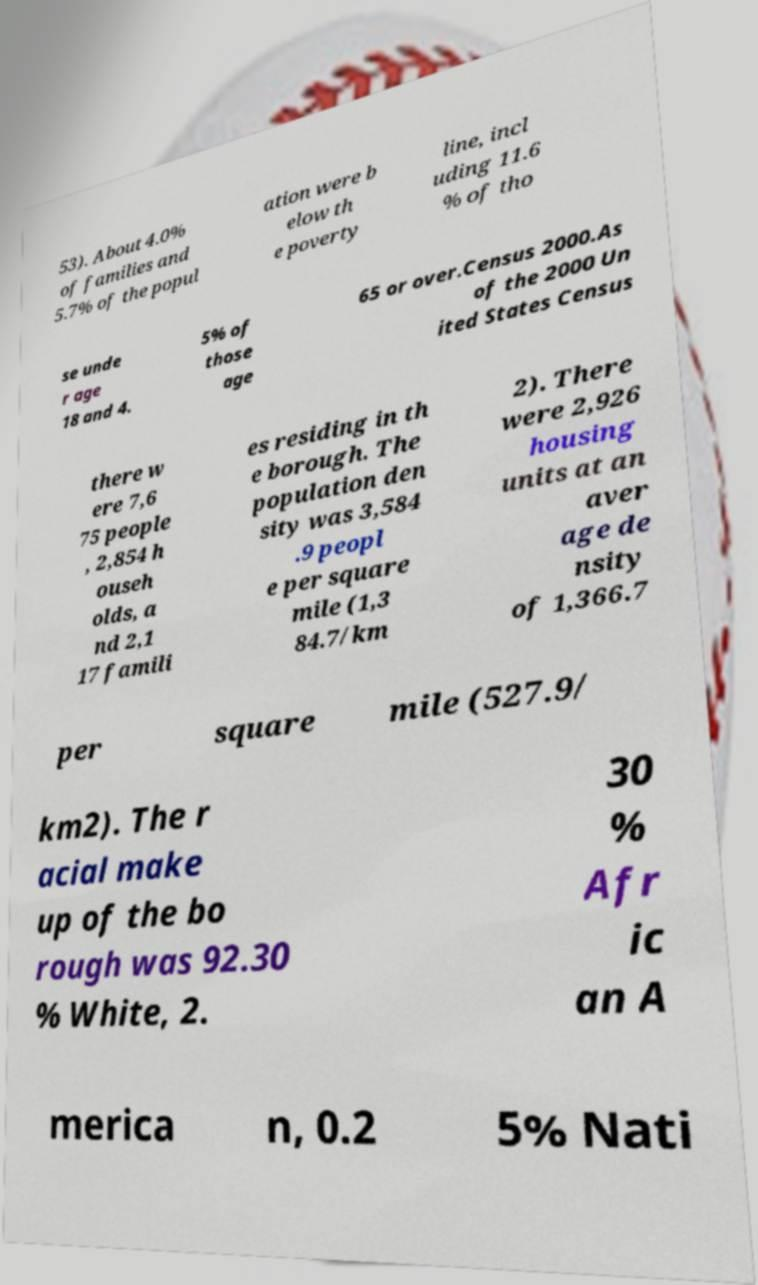What messages or text are displayed in this image? I need them in a readable, typed format. 53). About 4.0% of families and 5.7% of the popul ation were b elow th e poverty line, incl uding 11.6 % of tho se unde r age 18 and 4. 5% of those age 65 or over.Census 2000.As of the 2000 Un ited States Census there w ere 7,6 75 people , 2,854 h ouseh olds, a nd 2,1 17 famili es residing in th e borough. The population den sity was 3,584 .9 peopl e per square mile (1,3 84.7/km 2). There were 2,926 housing units at an aver age de nsity of 1,366.7 per square mile (527.9/ km2). The r acial make up of the bo rough was 92.30 % White, 2. 30 % Afr ic an A merica n, 0.2 5% Nati 